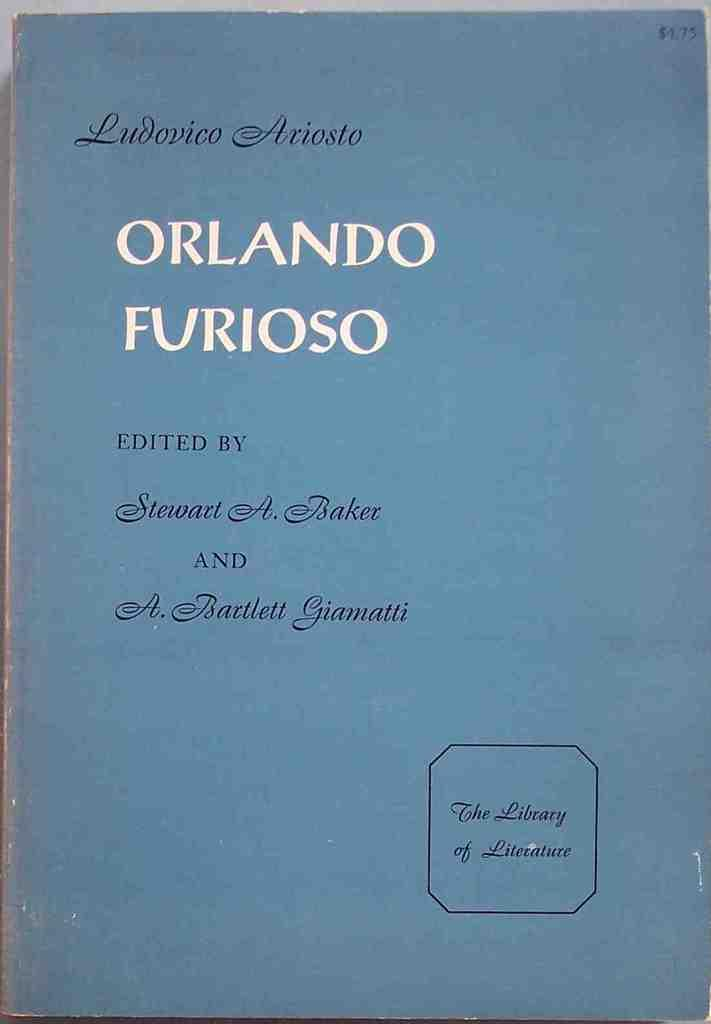<image>
Give a short and clear explanation of the subsequent image. A copy of Orlando Furioso brought for $4.75 